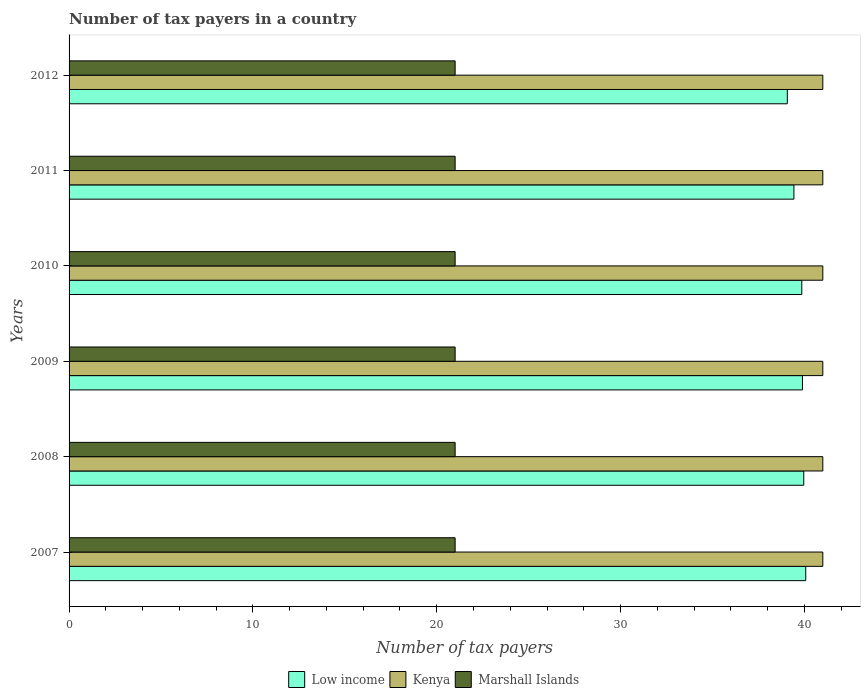How many groups of bars are there?
Ensure brevity in your answer.  6. Are the number of bars on each tick of the Y-axis equal?
Your answer should be compact. Yes. In how many cases, is the number of bars for a given year not equal to the number of legend labels?
Provide a short and direct response. 0. What is the number of tax payers in in Low income in 2009?
Provide a succinct answer. 39.89. Across all years, what is the maximum number of tax payers in in Marshall Islands?
Provide a short and direct response. 21. Across all years, what is the minimum number of tax payers in in Marshall Islands?
Your answer should be very brief. 21. What is the total number of tax payers in in Low income in the graph?
Make the answer very short. 238.28. What is the difference between the number of tax payers in in Low income in 2009 and that in 2010?
Make the answer very short. 0.04. What is the difference between the number of tax payers in in Kenya in 2008 and the number of tax payers in in Low income in 2007?
Offer a very short reply. 0.93. What is the average number of tax payers in in Marshall Islands per year?
Your answer should be compact. 21. In the year 2012, what is the difference between the number of tax payers in in Kenya and number of tax payers in in Low income?
Provide a short and direct response. 1.93. In how many years, is the number of tax payers in in Low income greater than 26 ?
Give a very brief answer. 6. What is the ratio of the number of tax payers in in Low income in 2008 to that in 2012?
Ensure brevity in your answer.  1.02. What is the difference between the highest and the lowest number of tax payers in in Low income?
Your answer should be very brief. 1. What does the 1st bar from the top in 2007 represents?
Your answer should be very brief. Marshall Islands. What does the 2nd bar from the bottom in 2012 represents?
Give a very brief answer. Kenya. Is it the case that in every year, the sum of the number of tax payers in in Low income and number of tax payers in in Kenya is greater than the number of tax payers in in Marshall Islands?
Your response must be concise. Yes. Does the graph contain any zero values?
Your answer should be very brief. No. How many legend labels are there?
Provide a succinct answer. 3. What is the title of the graph?
Make the answer very short. Number of tax payers in a country. What is the label or title of the X-axis?
Your answer should be very brief. Number of tax payers. What is the label or title of the Y-axis?
Offer a terse response. Years. What is the Number of tax payers in Low income in 2007?
Your answer should be very brief. 40.07. What is the Number of tax payers in Kenya in 2007?
Ensure brevity in your answer.  41. What is the Number of tax payers in Marshall Islands in 2007?
Offer a very short reply. 21. What is the Number of tax payers of Low income in 2008?
Provide a short and direct response. 39.96. What is the Number of tax payers of Marshall Islands in 2008?
Offer a very short reply. 21. What is the Number of tax payers of Low income in 2009?
Your answer should be very brief. 39.89. What is the Number of tax payers of Low income in 2010?
Offer a very short reply. 39.86. What is the Number of tax payers of Low income in 2011?
Give a very brief answer. 39.43. What is the Number of tax payers of Kenya in 2011?
Offer a terse response. 41. What is the Number of tax payers of Low income in 2012?
Provide a short and direct response. 39.07. Across all years, what is the maximum Number of tax payers of Low income?
Offer a very short reply. 40.07. Across all years, what is the maximum Number of tax payers in Kenya?
Give a very brief answer. 41. Across all years, what is the minimum Number of tax payers in Low income?
Your answer should be compact. 39.07. Across all years, what is the minimum Number of tax payers of Kenya?
Provide a succinct answer. 41. What is the total Number of tax payers in Low income in the graph?
Give a very brief answer. 238.28. What is the total Number of tax payers in Kenya in the graph?
Ensure brevity in your answer.  246. What is the total Number of tax payers of Marshall Islands in the graph?
Provide a succinct answer. 126. What is the difference between the Number of tax payers of Low income in 2007 and that in 2008?
Your response must be concise. 0.11. What is the difference between the Number of tax payers of Marshall Islands in 2007 and that in 2008?
Ensure brevity in your answer.  0. What is the difference between the Number of tax payers in Low income in 2007 and that in 2009?
Offer a terse response. 0.18. What is the difference between the Number of tax payers of Kenya in 2007 and that in 2009?
Give a very brief answer. 0. What is the difference between the Number of tax payers of Low income in 2007 and that in 2010?
Your answer should be compact. 0.21. What is the difference between the Number of tax payers in Kenya in 2007 and that in 2010?
Offer a terse response. 0. What is the difference between the Number of tax payers in Low income in 2007 and that in 2011?
Make the answer very short. 0.64. What is the difference between the Number of tax payers in Marshall Islands in 2007 and that in 2011?
Your answer should be very brief. 0. What is the difference between the Number of tax payers in Low income in 2007 and that in 2012?
Your answer should be very brief. 1. What is the difference between the Number of tax payers in Marshall Islands in 2007 and that in 2012?
Provide a short and direct response. 0. What is the difference between the Number of tax payers in Low income in 2008 and that in 2009?
Ensure brevity in your answer.  0.07. What is the difference between the Number of tax payers of Marshall Islands in 2008 and that in 2009?
Your answer should be very brief. 0. What is the difference between the Number of tax payers in Low income in 2008 and that in 2010?
Provide a succinct answer. 0.11. What is the difference between the Number of tax payers in Kenya in 2008 and that in 2010?
Give a very brief answer. 0. What is the difference between the Number of tax payers of Low income in 2008 and that in 2011?
Offer a terse response. 0.54. What is the difference between the Number of tax payers of Marshall Islands in 2008 and that in 2011?
Provide a succinct answer. 0. What is the difference between the Number of tax payers in Low income in 2008 and that in 2012?
Provide a succinct answer. 0.9. What is the difference between the Number of tax payers of Kenya in 2008 and that in 2012?
Offer a very short reply. 0. What is the difference between the Number of tax payers in Marshall Islands in 2008 and that in 2012?
Provide a succinct answer. 0. What is the difference between the Number of tax payers in Low income in 2009 and that in 2010?
Your answer should be very brief. 0.04. What is the difference between the Number of tax payers of Low income in 2009 and that in 2011?
Make the answer very short. 0.46. What is the difference between the Number of tax payers in Kenya in 2009 and that in 2011?
Offer a very short reply. 0. What is the difference between the Number of tax payers in Marshall Islands in 2009 and that in 2011?
Your answer should be very brief. 0. What is the difference between the Number of tax payers of Low income in 2009 and that in 2012?
Offer a terse response. 0.82. What is the difference between the Number of tax payers of Kenya in 2009 and that in 2012?
Ensure brevity in your answer.  0. What is the difference between the Number of tax payers of Low income in 2010 and that in 2011?
Offer a very short reply. 0.43. What is the difference between the Number of tax payers in Kenya in 2010 and that in 2011?
Make the answer very short. 0. What is the difference between the Number of tax payers in Marshall Islands in 2010 and that in 2011?
Your answer should be compact. 0. What is the difference between the Number of tax payers of Low income in 2010 and that in 2012?
Your answer should be very brief. 0.79. What is the difference between the Number of tax payers of Marshall Islands in 2010 and that in 2012?
Ensure brevity in your answer.  0. What is the difference between the Number of tax payers in Low income in 2011 and that in 2012?
Offer a very short reply. 0.36. What is the difference between the Number of tax payers in Kenya in 2011 and that in 2012?
Give a very brief answer. 0. What is the difference between the Number of tax payers in Marshall Islands in 2011 and that in 2012?
Your answer should be compact. 0. What is the difference between the Number of tax payers of Low income in 2007 and the Number of tax payers of Kenya in 2008?
Ensure brevity in your answer.  -0.93. What is the difference between the Number of tax payers of Low income in 2007 and the Number of tax payers of Marshall Islands in 2008?
Your response must be concise. 19.07. What is the difference between the Number of tax payers of Kenya in 2007 and the Number of tax payers of Marshall Islands in 2008?
Your answer should be very brief. 20. What is the difference between the Number of tax payers of Low income in 2007 and the Number of tax payers of Kenya in 2009?
Your answer should be compact. -0.93. What is the difference between the Number of tax payers in Low income in 2007 and the Number of tax payers in Marshall Islands in 2009?
Your response must be concise. 19.07. What is the difference between the Number of tax payers in Kenya in 2007 and the Number of tax payers in Marshall Islands in 2009?
Your answer should be compact. 20. What is the difference between the Number of tax payers in Low income in 2007 and the Number of tax payers in Kenya in 2010?
Provide a short and direct response. -0.93. What is the difference between the Number of tax payers in Low income in 2007 and the Number of tax payers in Marshall Islands in 2010?
Your response must be concise. 19.07. What is the difference between the Number of tax payers in Kenya in 2007 and the Number of tax payers in Marshall Islands in 2010?
Make the answer very short. 20. What is the difference between the Number of tax payers of Low income in 2007 and the Number of tax payers of Kenya in 2011?
Your answer should be compact. -0.93. What is the difference between the Number of tax payers of Low income in 2007 and the Number of tax payers of Marshall Islands in 2011?
Your answer should be very brief. 19.07. What is the difference between the Number of tax payers of Low income in 2007 and the Number of tax payers of Kenya in 2012?
Your response must be concise. -0.93. What is the difference between the Number of tax payers in Low income in 2007 and the Number of tax payers in Marshall Islands in 2012?
Give a very brief answer. 19.07. What is the difference between the Number of tax payers of Kenya in 2007 and the Number of tax payers of Marshall Islands in 2012?
Offer a terse response. 20. What is the difference between the Number of tax payers in Low income in 2008 and the Number of tax payers in Kenya in 2009?
Offer a terse response. -1.04. What is the difference between the Number of tax payers in Low income in 2008 and the Number of tax payers in Marshall Islands in 2009?
Provide a short and direct response. 18.96. What is the difference between the Number of tax payers of Kenya in 2008 and the Number of tax payers of Marshall Islands in 2009?
Offer a very short reply. 20. What is the difference between the Number of tax payers in Low income in 2008 and the Number of tax payers in Kenya in 2010?
Your answer should be compact. -1.04. What is the difference between the Number of tax payers in Low income in 2008 and the Number of tax payers in Marshall Islands in 2010?
Offer a terse response. 18.96. What is the difference between the Number of tax payers of Kenya in 2008 and the Number of tax payers of Marshall Islands in 2010?
Your response must be concise. 20. What is the difference between the Number of tax payers in Low income in 2008 and the Number of tax payers in Kenya in 2011?
Your response must be concise. -1.04. What is the difference between the Number of tax payers of Low income in 2008 and the Number of tax payers of Marshall Islands in 2011?
Provide a short and direct response. 18.96. What is the difference between the Number of tax payers in Low income in 2008 and the Number of tax payers in Kenya in 2012?
Provide a succinct answer. -1.04. What is the difference between the Number of tax payers of Low income in 2008 and the Number of tax payers of Marshall Islands in 2012?
Your answer should be compact. 18.96. What is the difference between the Number of tax payers in Low income in 2009 and the Number of tax payers in Kenya in 2010?
Ensure brevity in your answer.  -1.11. What is the difference between the Number of tax payers of Low income in 2009 and the Number of tax payers of Marshall Islands in 2010?
Keep it short and to the point. 18.89. What is the difference between the Number of tax payers of Kenya in 2009 and the Number of tax payers of Marshall Islands in 2010?
Provide a succinct answer. 20. What is the difference between the Number of tax payers in Low income in 2009 and the Number of tax payers in Kenya in 2011?
Provide a succinct answer. -1.11. What is the difference between the Number of tax payers in Low income in 2009 and the Number of tax payers in Marshall Islands in 2011?
Your answer should be compact. 18.89. What is the difference between the Number of tax payers in Kenya in 2009 and the Number of tax payers in Marshall Islands in 2011?
Your answer should be compact. 20. What is the difference between the Number of tax payers in Low income in 2009 and the Number of tax payers in Kenya in 2012?
Your answer should be compact. -1.11. What is the difference between the Number of tax payers in Low income in 2009 and the Number of tax payers in Marshall Islands in 2012?
Offer a very short reply. 18.89. What is the difference between the Number of tax payers of Low income in 2010 and the Number of tax payers of Kenya in 2011?
Your answer should be very brief. -1.14. What is the difference between the Number of tax payers of Low income in 2010 and the Number of tax payers of Marshall Islands in 2011?
Offer a terse response. 18.86. What is the difference between the Number of tax payers in Low income in 2010 and the Number of tax payers in Kenya in 2012?
Offer a very short reply. -1.14. What is the difference between the Number of tax payers of Low income in 2010 and the Number of tax payers of Marshall Islands in 2012?
Your response must be concise. 18.86. What is the difference between the Number of tax payers of Low income in 2011 and the Number of tax payers of Kenya in 2012?
Give a very brief answer. -1.57. What is the difference between the Number of tax payers of Low income in 2011 and the Number of tax payers of Marshall Islands in 2012?
Your answer should be very brief. 18.43. What is the average Number of tax payers of Low income per year?
Your answer should be compact. 39.71. What is the average Number of tax payers of Kenya per year?
Provide a short and direct response. 41. What is the average Number of tax payers in Marshall Islands per year?
Offer a terse response. 21. In the year 2007, what is the difference between the Number of tax payers in Low income and Number of tax payers in Kenya?
Provide a succinct answer. -0.93. In the year 2007, what is the difference between the Number of tax payers of Low income and Number of tax payers of Marshall Islands?
Your response must be concise. 19.07. In the year 2008, what is the difference between the Number of tax payers of Low income and Number of tax payers of Kenya?
Offer a terse response. -1.04. In the year 2008, what is the difference between the Number of tax payers of Low income and Number of tax payers of Marshall Islands?
Your answer should be compact. 18.96. In the year 2009, what is the difference between the Number of tax payers in Low income and Number of tax payers in Kenya?
Your answer should be very brief. -1.11. In the year 2009, what is the difference between the Number of tax payers in Low income and Number of tax payers in Marshall Islands?
Your answer should be very brief. 18.89. In the year 2010, what is the difference between the Number of tax payers of Low income and Number of tax payers of Kenya?
Provide a succinct answer. -1.14. In the year 2010, what is the difference between the Number of tax payers of Low income and Number of tax payers of Marshall Islands?
Your answer should be very brief. 18.86. In the year 2010, what is the difference between the Number of tax payers of Kenya and Number of tax payers of Marshall Islands?
Give a very brief answer. 20. In the year 2011, what is the difference between the Number of tax payers in Low income and Number of tax payers in Kenya?
Your answer should be compact. -1.57. In the year 2011, what is the difference between the Number of tax payers in Low income and Number of tax payers in Marshall Islands?
Give a very brief answer. 18.43. In the year 2011, what is the difference between the Number of tax payers in Kenya and Number of tax payers in Marshall Islands?
Your response must be concise. 20. In the year 2012, what is the difference between the Number of tax payers in Low income and Number of tax payers in Kenya?
Offer a terse response. -1.93. In the year 2012, what is the difference between the Number of tax payers of Low income and Number of tax payers of Marshall Islands?
Offer a very short reply. 18.07. What is the ratio of the Number of tax payers in Low income in 2007 to that in 2008?
Provide a succinct answer. 1. What is the ratio of the Number of tax payers in Marshall Islands in 2007 to that in 2008?
Offer a very short reply. 1. What is the ratio of the Number of tax payers in Low income in 2007 to that in 2009?
Offer a terse response. 1. What is the ratio of the Number of tax payers in Marshall Islands in 2007 to that in 2009?
Offer a very short reply. 1. What is the ratio of the Number of tax payers of Low income in 2007 to that in 2010?
Make the answer very short. 1.01. What is the ratio of the Number of tax payers in Marshall Islands in 2007 to that in 2010?
Provide a succinct answer. 1. What is the ratio of the Number of tax payers of Low income in 2007 to that in 2011?
Your answer should be compact. 1.02. What is the ratio of the Number of tax payers of Low income in 2007 to that in 2012?
Provide a short and direct response. 1.03. What is the ratio of the Number of tax payers in Kenya in 2008 to that in 2009?
Give a very brief answer. 1. What is the ratio of the Number of tax payers of Low income in 2008 to that in 2010?
Your answer should be compact. 1. What is the ratio of the Number of tax payers of Kenya in 2008 to that in 2010?
Provide a short and direct response. 1. What is the ratio of the Number of tax payers in Marshall Islands in 2008 to that in 2010?
Ensure brevity in your answer.  1. What is the ratio of the Number of tax payers in Low income in 2008 to that in 2011?
Make the answer very short. 1.01. What is the ratio of the Number of tax payers of Marshall Islands in 2008 to that in 2011?
Keep it short and to the point. 1. What is the ratio of the Number of tax payers of Low income in 2008 to that in 2012?
Your response must be concise. 1.02. What is the ratio of the Number of tax payers in Kenya in 2008 to that in 2012?
Offer a very short reply. 1. What is the ratio of the Number of tax payers in Low income in 2009 to that in 2010?
Offer a terse response. 1. What is the ratio of the Number of tax payers in Low income in 2009 to that in 2011?
Ensure brevity in your answer.  1.01. What is the ratio of the Number of tax payers of Kenya in 2009 to that in 2011?
Provide a succinct answer. 1. What is the ratio of the Number of tax payers in Low income in 2009 to that in 2012?
Keep it short and to the point. 1.02. What is the ratio of the Number of tax payers in Kenya in 2009 to that in 2012?
Your response must be concise. 1. What is the ratio of the Number of tax payers of Low income in 2010 to that in 2011?
Your answer should be compact. 1.01. What is the ratio of the Number of tax payers in Marshall Islands in 2010 to that in 2011?
Your answer should be compact. 1. What is the ratio of the Number of tax payers in Low income in 2010 to that in 2012?
Provide a succinct answer. 1.02. What is the ratio of the Number of tax payers of Kenya in 2010 to that in 2012?
Provide a succinct answer. 1. What is the ratio of the Number of tax payers of Marshall Islands in 2010 to that in 2012?
Ensure brevity in your answer.  1. What is the ratio of the Number of tax payers in Low income in 2011 to that in 2012?
Offer a terse response. 1.01. What is the ratio of the Number of tax payers of Kenya in 2011 to that in 2012?
Give a very brief answer. 1. What is the ratio of the Number of tax payers of Marshall Islands in 2011 to that in 2012?
Provide a short and direct response. 1. What is the difference between the highest and the second highest Number of tax payers of Low income?
Offer a very short reply. 0.11. What is the difference between the highest and the second highest Number of tax payers of Kenya?
Your answer should be compact. 0. What is the difference between the highest and the second highest Number of tax payers of Marshall Islands?
Offer a terse response. 0. What is the difference between the highest and the lowest Number of tax payers in Low income?
Your answer should be very brief. 1. What is the difference between the highest and the lowest Number of tax payers of Kenya?
Offer a terse response. 0. 